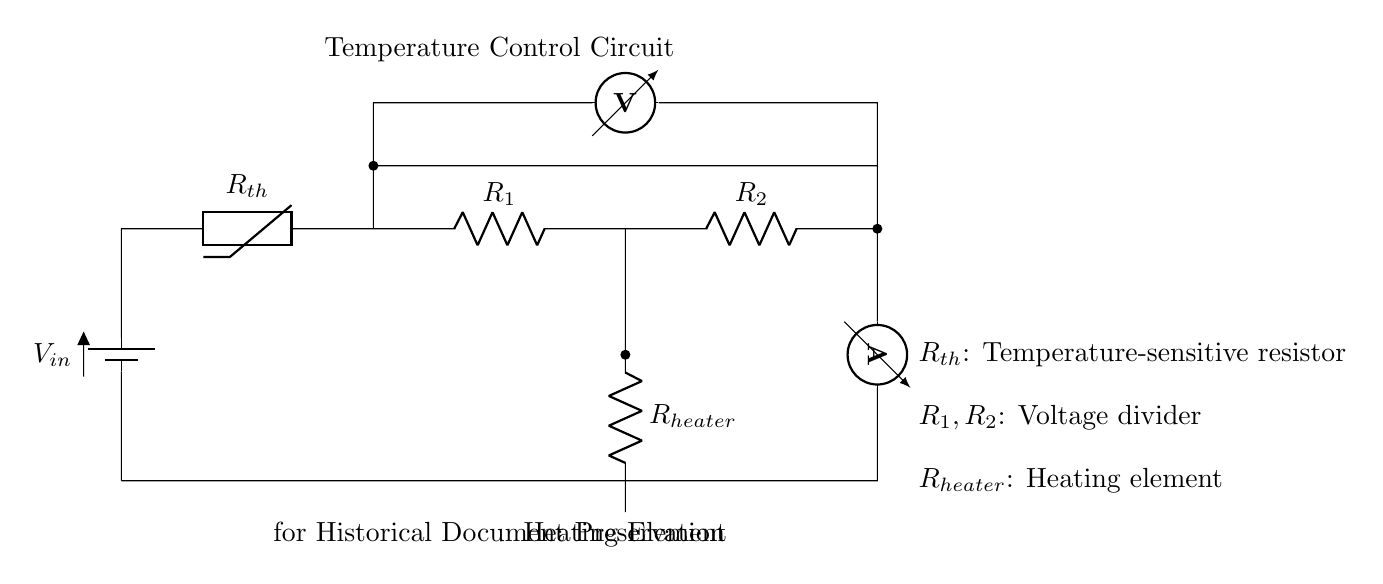What is the input voltage of this circuit? The circuit includes a battery labeled \(V_{in}\), which represents the input voltage.
Answer: \(V_{in}\) What type of resistor is used for temperature sensing? The circuit diagram shows a thermistor symbol labeled \(R_{th}\), indicating that it is a temperature-sensitive resistor.
Answer: Thermistor How many resistors are involved in voltage division? There are two resistors labeled \(R_1\) and \(R_2\) connected in series, indicating they are part of a voltage divider configuration.
Answer: Two What is the purpose of the heating element in this circuit? The heating element labeled \(R_{heater}\) is used to control the temperature in the circuit to ensure the preservation of delicate historical documents.
Answer: Temperature control What is the function of the ammeter in this circuit? The ammeter measures the current flowing through the circuit, which is important for understanding the performance of the heating element and overall circuit operation.
Answer: Measure current If the temperature exceeds a set threshold, what will likely happen to the thermistor's resistance? As temperature increases, the resistance of a thermistor typically decreases, which affects the voltage division and overall circuit response.
Answer: Decrease What role do resistors \(R_1\) and \(R_2\) play in conjunction with the thermistor? Resistors \(R_1\) and \(R_2\) together form a voltage divider that helps to determine the voltage drop across the thermistor, which is critical for the temperature control logic.
Answer: Voltage divider 